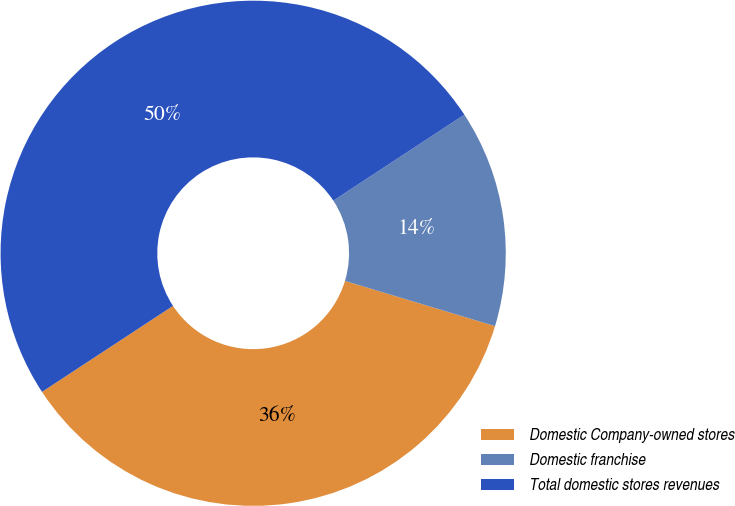Convert chart to OTSL. <chart><loc_0><loc_0><loc_500><loc_500><pie_chart><fcel>Domestic Company-owned stores<fcel>Domestic franchise<fcel>Total domestic stores revenues<nl><fcel>36.1%<fcel>13.9%<fcel>50.0%<nl></chart> 